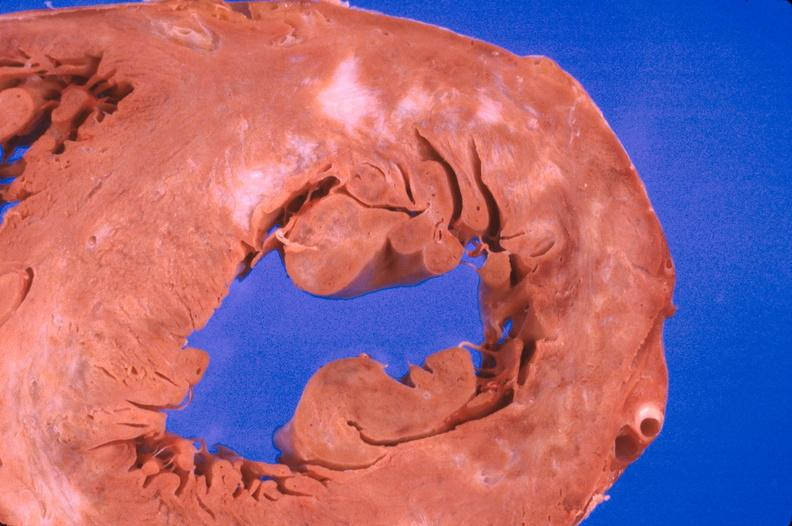does abdomen show heart, myocardial infarction free wall, 6 days old, in a patient with diabetes mellitus and hypertension?
Answer the question using a single word or phrase. No 